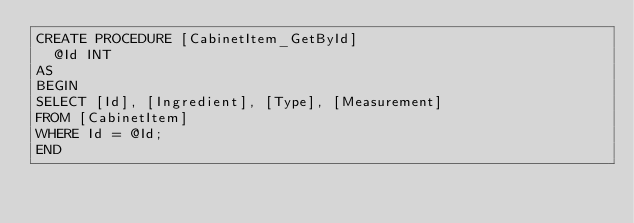<code> <loc_0><loc_0><loc_500><loc_500><_SQL_>CREATE PROCEDURE [CabinetItem_GetById]
	@Id INT
AS
BEGIN
SELECT [Id], [Ingredient], [Type], [Measurement]
FROM [CabinetItem]
WHERE Id = @Id;
END
</code> 